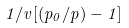Convert formula to latex. <formula><loc_0><loc_0><loc_500><loc_500>1 / v [ ( p _ { 0 } / p ) - 1 ]</formula> 